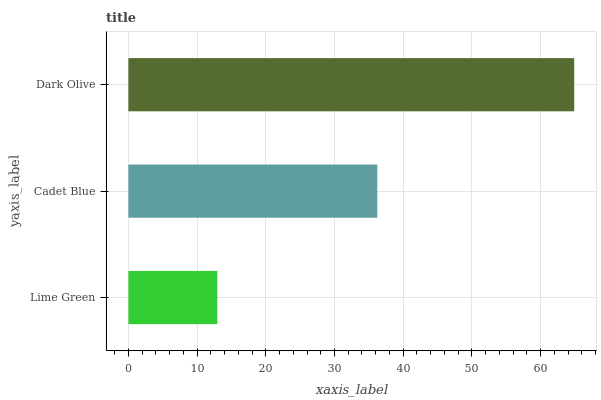Is Lime Green the minimum?
Answer yes or no. Yes. Is Dark Olive the maximum?
Answer yes or no. Yes. Is Cadet Blue the minimum?
Answer yes or no. No. Is Cadet Blue the maximum?
Answer yes or no. No. Is Cadet Blue greater than Lime Green?
Answer yes or no. Yes. Is Lime Green less than Cadet Blue?
Answer yes or no. Yes. Is Lime Green greater than Cadet Blue?
Answer yes or no. No. Is Cadet Blue less than Lime Green?
Answer yes or no. No. Is Cadet Blue the high median?
Answer yes or no. Yes. Is Cadet Blue the low median?
Answer yes or no. Yes. Is Dark Olive the high median?
Answer yes or no. No. Is Lime Green the low median?
Answer yes or no. No. 